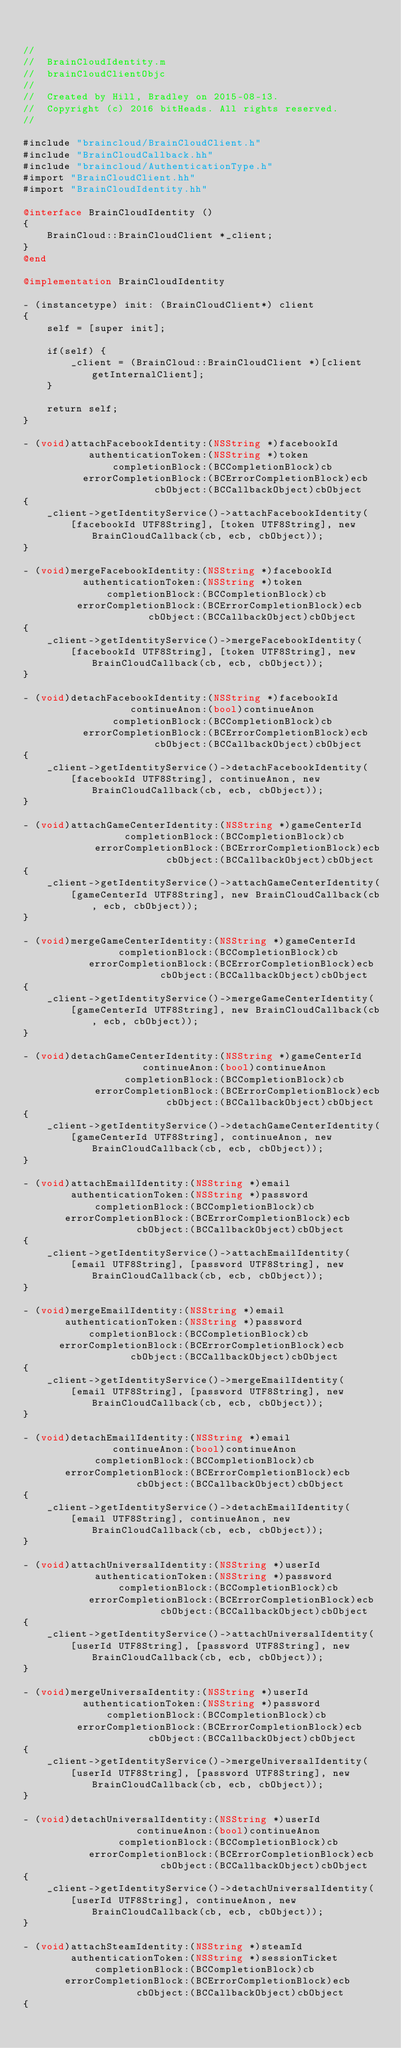<code> <loc_0><loc_0><loc_500><loc_500><_ObjectiveC_>
    
//
//  BrainCloudIdentity.m
//  brainCloudClientObjc
//
//  Created by Hill, Bradley on 2015-08-13.
//  Copyright (c) 2016 bitHeads. All rights reserved.
//

#include "braincloud/BrainCloudClient.h"
#include "BrainCloudCallback.hh"
#include "braincloud/AuthenticationType.h"
#import "BrainCloudClient.hh"
#import "BrainCloudIdentity.hh"

@interface BrainCloudIdentity ()
{
    BrainCloud::BrainCloudClient *_client;
}
@end

@implementation BrainCloudIdentity

- (instancetype) init: (BrainCloudClient*) client
{
    self = [super init];

    if(self) {
        _client = (BrainCloud::BrainCloudClient *)[client getInternalClient];
    }

    return self;
}

- (void)attachFacebookIdentity:(NSString *)facebookId
           authenticationToken:(NSString *)token
               completionBlock:(BCCompletionBlock)cb
          errorCompletionBlock:(BCErrorCompletionBlock)ecb
                      cbObject:(BCCallbackObject)cbObject
{
    _client->getIdentityService()->attachFacebookIdentity(
        [facebookId UTF8String], [token UTF8String], new BrainCloudCallback(cb, ecb, cbObject));
}

- (void)mergeFacebookIdentity:(NSString *)facebookId
          authenticationToken:(NSString *)token
              completionBlock:(BCCompletionBlock)cb
         errorCompletionBlock:(BCErrorCompletionBlock)ecb
                     cbObject:(BCCallbackObject)cbObject
{
    _client->getIdentityService()->mergeFacebookIdentity(
        [facebookId UTF8String], [token UTF8String], new BrainCloudCallback(cb, ecb, cbObject));
}

- (void)detachFacebookIdentity:(NSString *)facebookId
                  continueAnon:(bool)continueAnon
               completionBlock:(BCCompletionBlock)cb
          errorCompletionBlock:(BCErrorCompletionBlock)ecb
                      cbObject:(BCCallbackObject)cbObject
{
    _client->getIdentityService()->detachFacebookIdentity(
        [facebookId UTF8String], continueAnon, new BrainCloudCallback(cb, ecb, cbObject));
}

- (void)attachGameCenterIdentity:(NSString *)gameCenterId
                 completionBlock:(BCCompletionBlock)cb
            errorCompletionBlock:(BCErrorCompletionBlock)ecb
                        cbObject:(BCCallbackObject)cbObject
{
    _client->getIdentityService()->attachGameCenterIdentity(
        [gameCenterId UTF8String], new BrainCloudCallback(cb, ecb, cbObject));
}

- (void)mergeGameCenterIdentity:(NSString *)gameCenterId
                completionBlock:(BCCompletionBlock)cb
           errorCompletionBlock:(BCErrorCompletionBlock)ecb
                       cbObject:(BCCallbackObject)cbObject
{
    _client->getIdentityService()->mergeGameCenterIdentity(
        [gameCenterId UTF8String], new BrainCloudCallback(cb, ecb, cbObject));
}

- (void)detachGameCenterIdentity:(NSString *)gameCenterId
                    continueAnon:(bool)continueAnon
                 completionBlock:(BCCompletionBlock)cb
            errorCompletionBlock:(BCErrorCompletionBlock)ecb
                        cbObject:(BCCallbackObject)cbObject
{
    _client->getIdentityService()->detachGameCenterIdentity(
        [gameCenterId UTF8String], continueAnon, new BrainCloudCallback(cb, ecb, cbObject));
}

- (void)attachEmailIdentity:(NSString *)email
        authenticationToken:(NSString *)password
            completionBlock:(BCCompletionBlock)cb
       errorCompletionBlock:(BCErrorCompletionBlock)ecb
                   cbObject:(BCCallbackObject)cbObject
{
    _client->getIdentityService()->attachEmailIdentity(
        [email UTF8String], [password UTF8String], new BrainCloudCallback(cb, ecb, cbObject));
}

- (void)mergeEmailIdentity:(NSString *)email
       authenticationToken:(NSString *)password
           completionBlock:(BCCompletionBlock)cb
      errorCompletionBlock:(BCErrorCompletionBlock)ecb
                  cbObject:(BCCallbackObject)cbObject
{
    _client->getIdentityService()->mergeEmailIdentity(
        [email UTF8String], [password UTF8String], new BrainCloudCallback(cb, ecb, cbObject));
}

- (void)detachEmailIdentity:(NSString *)email
               continueAnon:(bool)continueAnon
            completionBlock:(BCCompletionBlock)cb
       errorCompletionBlock:(BCErrorCompletionBlock)ecb
                   cbObject:(BCCallbackObject)cbObject
{
    _client->getIdentityService()->detachEmailIdentity(
        [email UTF8String], continueAnon, new BrainCloudCallback(cb, ecb, cbObject));
}

- (void)attachUniversalIdentity:(NSString *)userId
            authenticationToken:(NSString *)password
                completionBlock:(BCCompletionBlock)cb
           errorCompletionBlock:(BCErrorCompletionBlock)ecb
                       cbObject:(BCCallbackObject)cbObject
{
    _client->getIdentityService()->attachUniversalIdentity(
        [userId UTF8String], [password UTF8String], new BrainCloudCallback(cb, ecb, cbObject));
}

- (void)mergeUniversaIdentity:(NSString *)userId
          authenticationToken:(NSString *)password
              completionBlock:(BCCompletionBlock)cb
         errorCompletionBlock:(BCErrorCompletionBlock)ecb
                     cbObject:(BCCallbackObject)cbObject
{
    _client->getIdentityService()->mergeUniversalIdentity(
        [userId UTF8String], [password UTF8String], new BrainCloudCallback(cb, ecb, cbObject));
}

- (void)detachUniversalIdentity:(NSString *)userId
                   continueAnon:(bool)continueAnon
                completionBlock:(BCCompletionBlock)cb
           errorCompletionBlock:(BCErrorCompletionBlock)ecb
                       cbObject:(BCCallbackObject)cbObject
{
    _client->getIdentityService()->detachUniversalIdentity(
        [userId UTF8String], continueAnon, new BrainCloudCallback(cb, ecb, cbObject));
}

- (void)attachSteamIdentity:(NSString *)steamId
        authenticationToken:(NSString *)sessionTicket
            completionBlock:(BCCompletionBlock)cb
       errorCompletionBlock:(BCErrorCompletionBlock)ecb
                   cbObject:(BCCallbackObject)cbObject
{</code> 